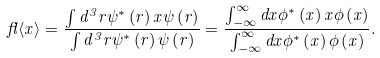<formula> <loc_0><loc_0><loc_500><loc_500>\ f l \langle x \rangle = \frac { \int d ^ { 3 } r \psi ^ { \ast } \left ( { r } \right ) x \psi \left ( { r } \right ) } { \int d ^ { 3 } r \psi ^ { \ast } \left ( { r } \right ) \psi \left ( { r } \right ) } = \frac { \int _ { - \infty } ^ { \infty } d x \phi ^ { \ast } \left ( x \right ) x \phi \left ( x \right ) } { \int _ { - \infty } ^ { \infty } d x \phi ^ { \ast } \left ( x \right ) \phi \left ( x \right ) } .</formula> 